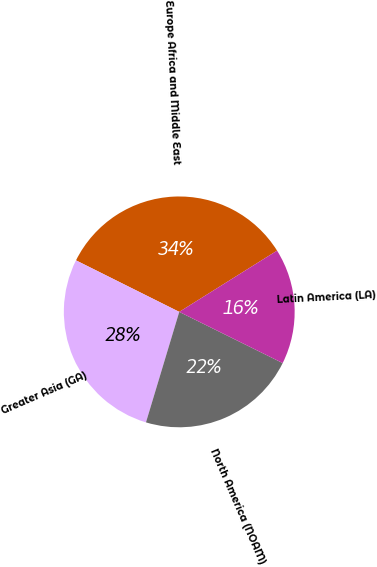Convert chart to OTSL. <chart><loc_0><loc_0><loc_500><loc_500><pie_chart><fcel>Europe Africa and Middle East<fcel>Greater Asia (GA)<fcel>North America (NOAM)<fcel>Latin America (LA)<nl><fcel>33.73%<fcel>27.71%<fcel>22.34%<fcel>16.22%<nl></chart> 